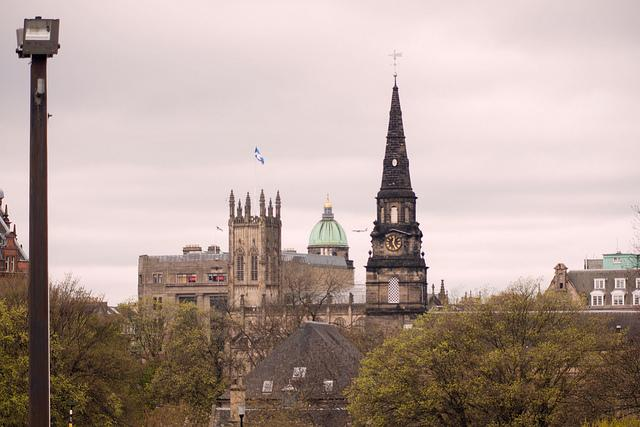What color is the wide dome in the background of the church? Please explain your reasoning. blue copper. The dome in the background of this city skyline is a pale blue. 